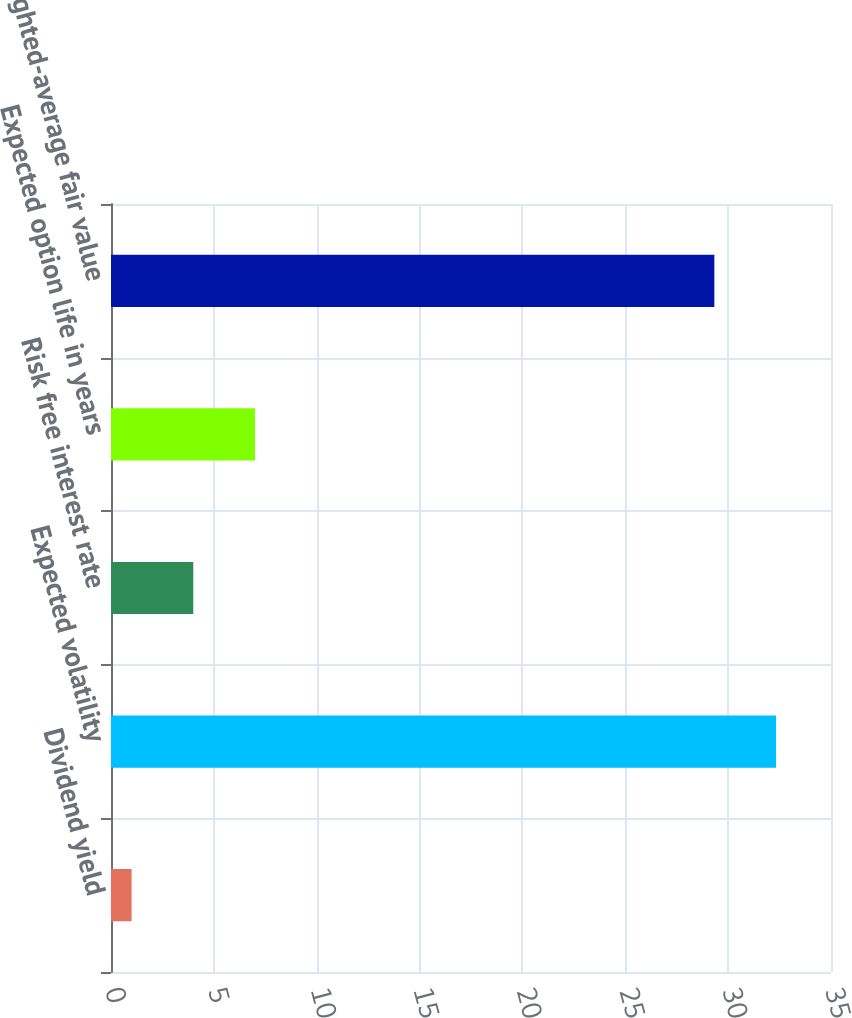<chart> <loc_0><loc_0><loc_500><loc_500><bar_chart><fcel>Dividend yield<fcel>Expected volatility<fcel>Risk free interest rate<fcel>Expected option life in years<fcel>Weighted-average fair value<nl><fcel>1<fcel>32.33<fcel>4<fcel>7<fcel>29.33<nl></chart> 